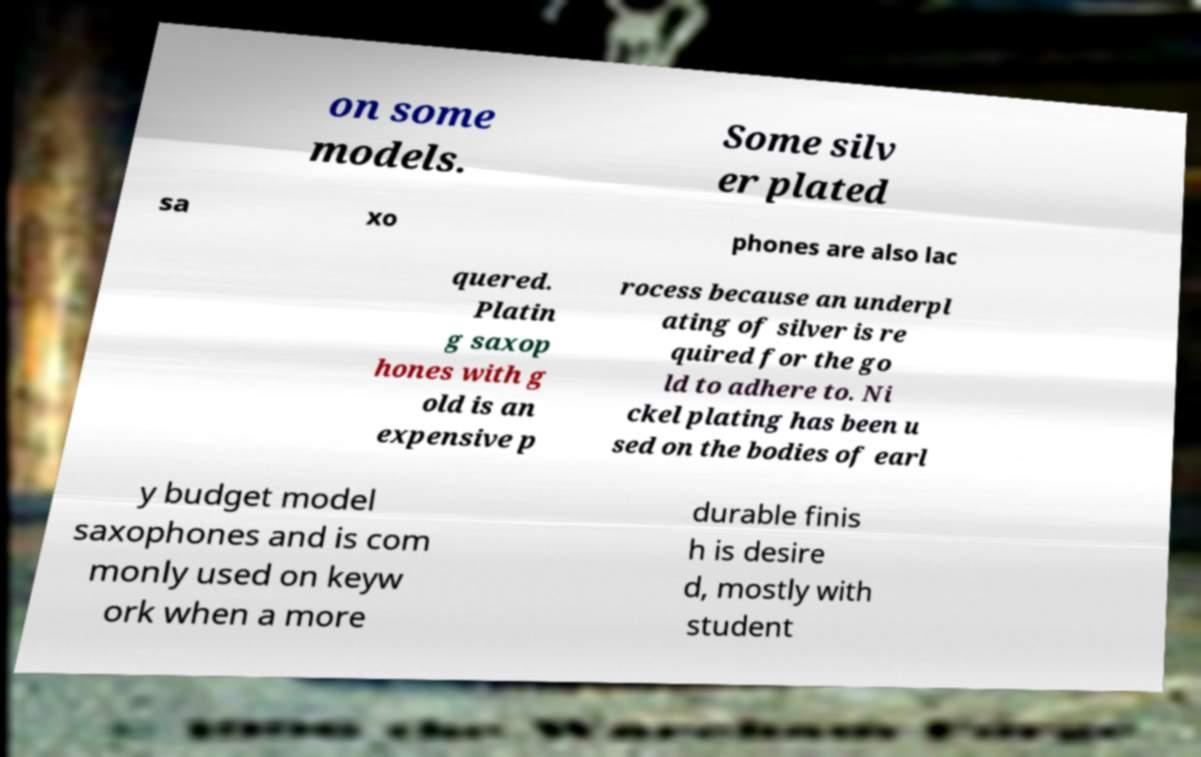Could you extract and type out the text from this image? on some models. Some silv er plated sa xo phones are also lac quered. Platin g saxop hones with g old is an expensive p rocess because an underpl ating of silver is re quired for the go ld to adhere to. Ni ckel plating has been u sed on the bodies of earl y budget model saxophones and is com monly used on keyw ork when a more durable finis h is desire d, mostly with student 